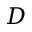Convert formula to latex. <formula><loc_0><loc_0><loc_500><loc_500>D</formula> 